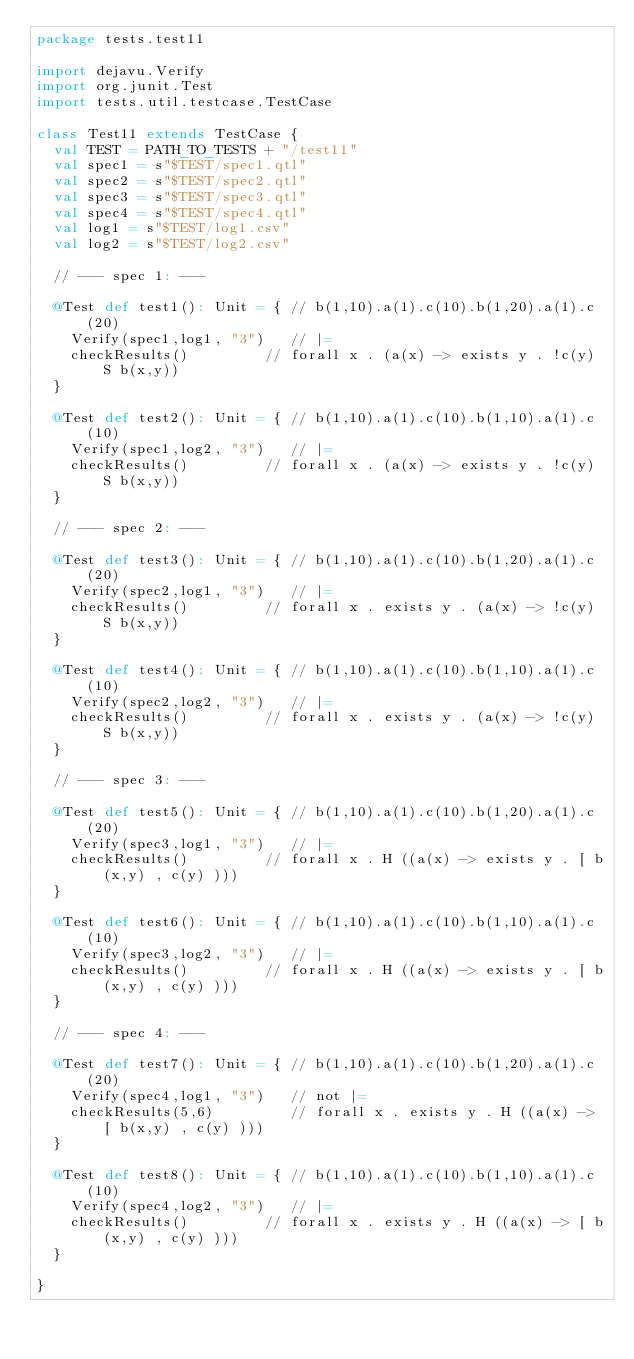<code> <loc_0><loc_0><loc_500><loc_500><_Scala_>package tests.test11

import dejavu.Verify
import org.junit.Test
import tests.util.testcase.TestCase

class Test11 extends TestCase {
  val TEST = PATH_TO_TESTS + "/test11"
  val spec1 = s"$TEST/spec1.qtl"
  val spec2 = s"$TEST/spec2.qtl"
  val spec3 = s"$TEST/spec3.qtl"
  val spec4 = s"$TEST/spec4.qtl"
  val log1 = s"$TEST/log1.csv"
  val log2 = s"$TEST/log2.csv"

  // --- spec 1: ---

  @Test def test1(): Unit = { // b(1,10).a(1).c(10).b(1,20).a(1).c(20)
    Verify(spec1,log1, "3")   // |=
    checkResults()         // forall x . (a(x) -> exists y . !c(y) S b(x,y))
  }

  @Test def test2(): Unit = { // b(1,10).a(1).c(10).b(1,10).a(1).c(10)
    Verify(spec1,log2, "3")   // |=
    checkResults()         // forall x . (a(x) -> exists y . !c(y) S b(x,y))
  }

  // --- spec 2: ---

  @Test def test3(): Unit = { // b(1,10).a(1).c(10).b(1,20).a(1).c(20)
    Verify(spec2,log1, "3")   // |=
    checkResults()         // forall x . exists y . (a(x) -> !c(y) S b(x,y))
  }

  @Test def test4(): Unit = { // b(1,10).a(1).c(10).b(1,10).a(1).c(10)
    Verify(spec2,log2, "3")   // |=
    checkResults()         // forall x . exists y . (a(x) -> !c(y) S b(x,y))
  }

  // --- spec 3: ---

  @Test def test5(): Unit = { // b(1,10).a(1).c(10).b(1,20).a(1).c(20)
    Verify(spec3,log1, "3")   // |=
    checkResults()         // forall x . H ((a(x) -> exists y . [ b(x,y) , c(y) )))
  }

  @Test def test6(): Unit = { // b(1,10).a(1).c(10).b(1,10).a(1).c(10)
    Verify(spec3,log2, "3")   // |=
    checkResults()         // forall x . H ((a(x) -> exists y . [ b(x,y) , c(y) )))
  }

  // --- spec 4: ---

  @Test def test7(): Unit = { // b(1,10).a(1).c(10).b(1,20).a(1).c(20)
    Verify(spec4,log1, "3")   // not |=
    checkResults(5,6)         // forall x . exists y . H ((a(x) -> [ b(x,y) , c(y) )))
  }

  @Test def test8(): Unit = { // b(1,10).a(1).c(10).b(1,10).a(1).c(10)
    Verify(spec4,log2, "3")   // |=
    checkResults()         // forall x . exists y . H ((a(x) -> [ b(x,y) , c(y) )))
  }

}

</code> 